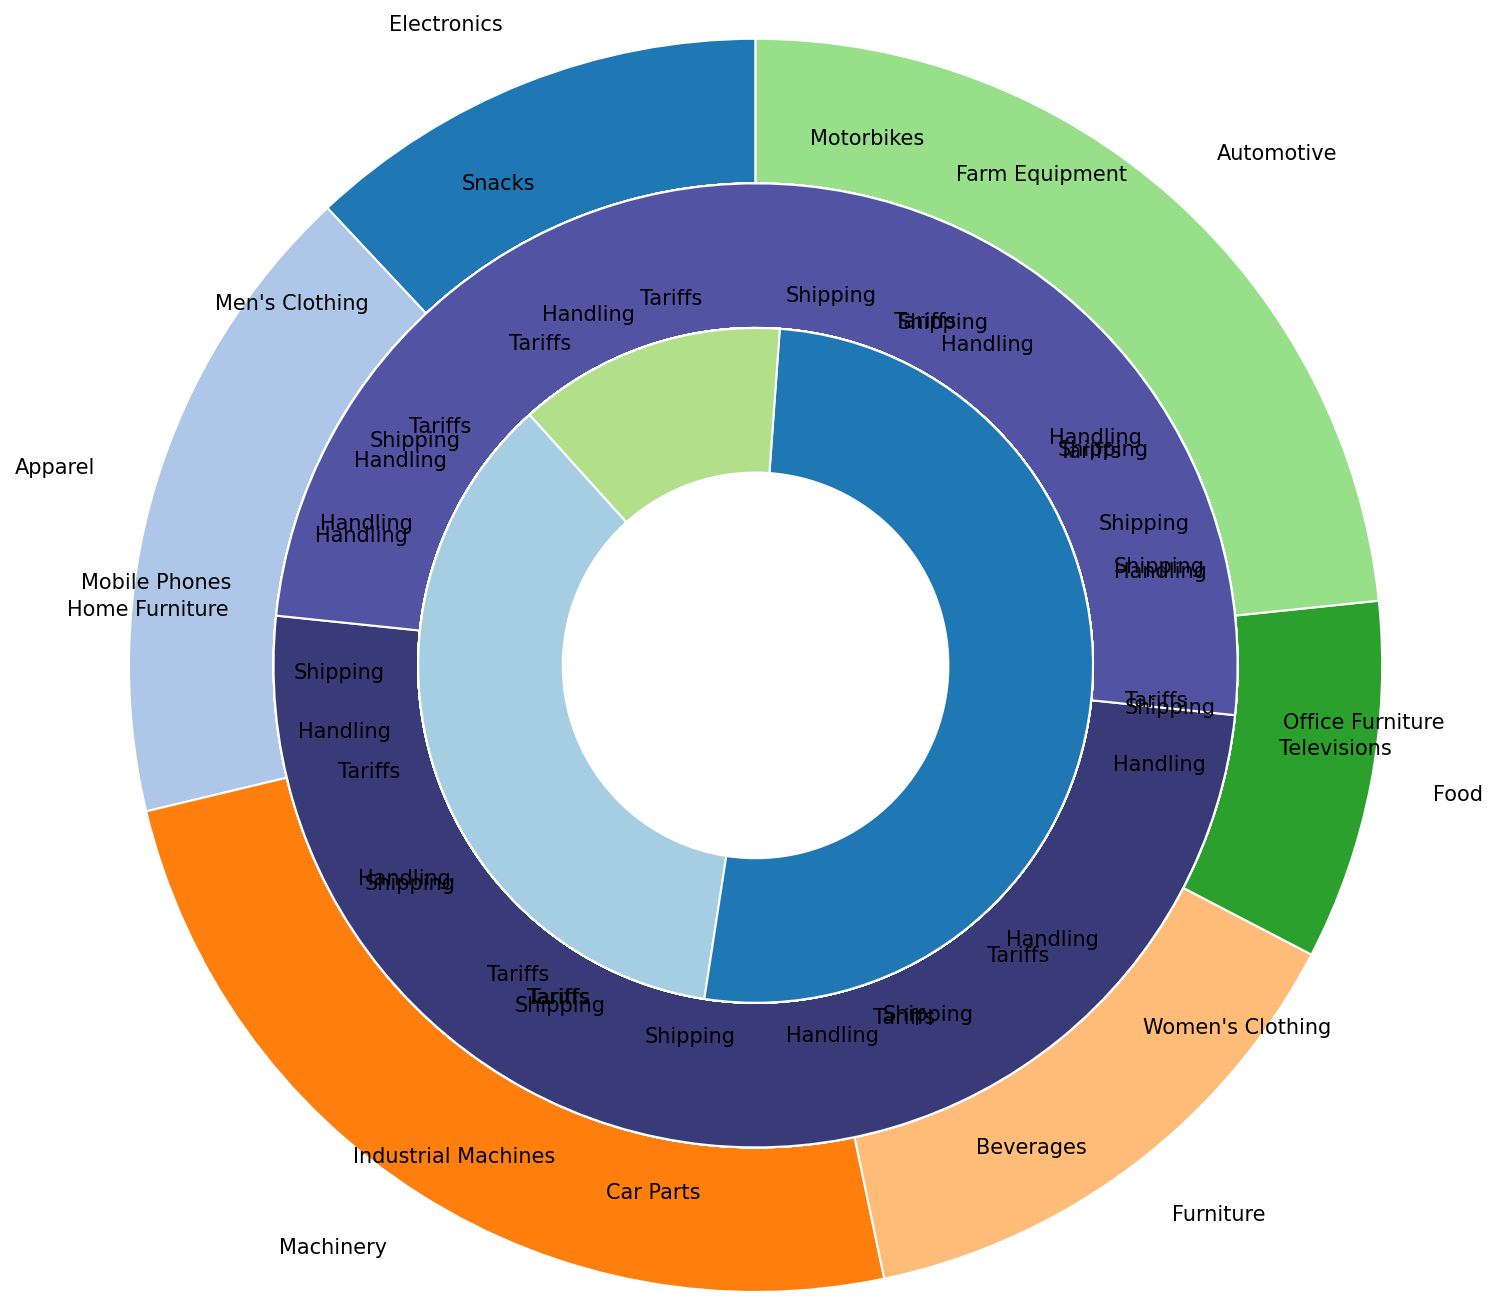Which category has the highest percentage cost for tariffs? By visually inspecting the outermost ring of the chart and comparing the segments labeled with "Tariffs," identify the largest segment. "Automotive" appears to have the largest segment.
Answer: Automotive What is the difference in shipping costs between Men's Clothing and Televisions? Identify the segments for "Shipping" within the subcategories "Men's Clothing" and "Televisions." Men's Clothing has 15% for Shipping, while Televisions have 12%. The difference is 15% - 12% = 3%.
Answer: 3% What is the total percentage for cost components of Mobile Phones? Sum the percentages for Mobile Phones' "Tariffs" (5%), "Shipping" (10%), and "Handling" (3%). The total is 5% + 10% + 3% = 18%.
Answer: 18% Which subcategory in Electronics has a higher shipping cost, Mobile Phones or Televisions? Compare the segments for "Shipping" within the subcategories "Mobile Phones" and "Televisions." Mobile Phones have a "Shipping" percentage of 10%, whereas Televisions have 12%. Televisions have a higher shipping cost.
Answer: Televisions What is the combined percentage of handling costs for all food subcategories? Add the percentages for "Handling" in "Beverages" (4%) and "Snacks" (3%). The total handling cost for Food is 4% + 3% = 7%.
Answer: 7% Which subcategory in Automotive has a lower tariff percentage, Car Parts or Motorbikes? Compare the segments for "Tariffs" within the subcategories "Car Parts" and "Motorbikes." Car Parts have a "Tariffs" percentage of 15%, while Motorbikes have 14%. Therefore, Motorbikes have a lower tariff percentage.
Answer: Motorbikes What is the average percentage cost for handling across all Furniture subcategories? Sum the percentages for "Handling" in "Office Furniture" (6%) and "Home Furniture" (5%), then divide by the number of subcategories: (6% + 5%) / 2 = 5.5%.
Answer: 5.5% Which category contributes the least to total shipping costs? By visually inspecting the segments for "Shipping" across all categories, find the smallest segment. "Food" appears to have the smallest segment for shipping costs.
Answer: Food What is the percentage difference between tariffs for Farm Equipment and Industrial Machines? Identify the segments for "Tariffs" within the subcategories "Farm Equipment" (10%) and "Industrial Machines" (12%). The difference is 12% - 10% = 2%.
Answer: 2% Which has a higher total cost percentage, Office Furniture or Beverages? Sum the percentages for all cost components in "Office Furniture" (7% + 12% + 6%) and "Beverages" (3% + 8% + 4%). Office Furniture totals to 25%, and Beverages total to 15%. Office Furniture has a higher total cost percentage.
Answer: Office Furniture 